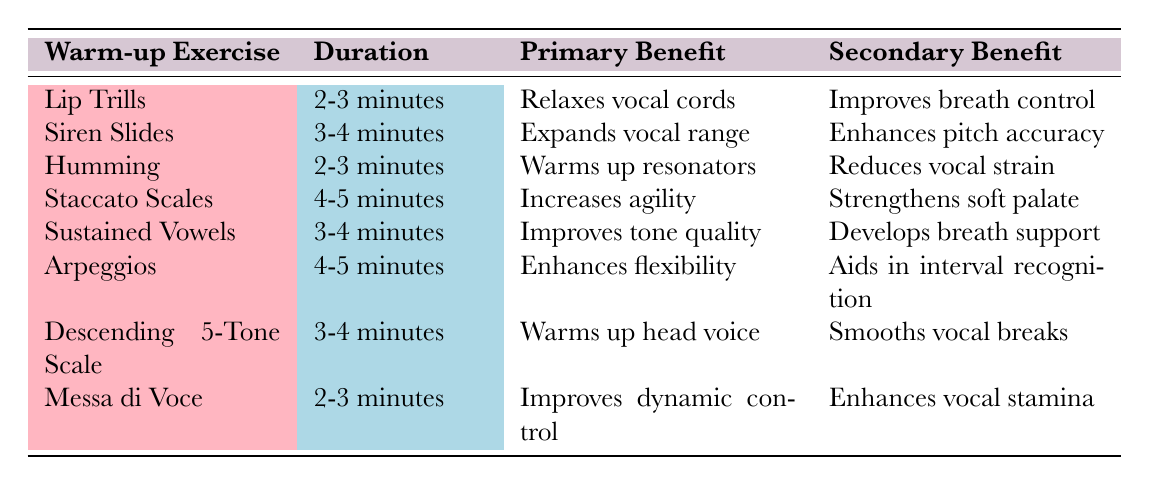What is the primary benefit of Lip Trills? Lip Trills have the primary benefit of relaxing the vocal cords, as indicated in the table.
Answer: Relaxes vocal cords How long should one practice Humming? According to the table, Humming should be practiced for 2-3 minutes.
Answer: 2-3 minutes Do Staccato Scales improve breath control? The table does not list breath control as a benefit of Staccato Scales, so this statement is false.
Answer: No Which exercise has the longest recommended duration? Staccato Scales and Arpeggios both have the longest duration of 4-5 minutes. This is determined by comparing the duration values in the table.
Answer: Staccato Scales and Arpeggios What is the secondary benefit of Sustained Vowels? The secondary benefit of Sustained Vowels is to develop breath support, as shown in the table.
Answer: Develops breath support Which warm-up exercise is said to enhance pitch accuracy? The table indicates that Siren Slides enhance pitch accuracy.
Answer: Siren Slides What is the average duration of the exercises listed? The durations listed are 2-3, 3-4, and 4-5 minutes. Converting these ranges to numeric values (2.5, 3.5, and 4.5 on average) and averaging gives (2.5 + 3.5 + 4.5)/8 = 3.5 minutes.
Answer: 3.5 minutes Is it true that the Messa di Voce improves vocal stamina? Yes, based on the table, Messa di Voce lists enhancing vocal stamina as its secondary benefit, making this statement true.
Answer: Yes Which exercise focuses on warming up the head voice? The exercise that warms up the head voice, as stated in the table, is the Descending 5-Tone Scale.
Answer: Descending 5-Tone Scale 